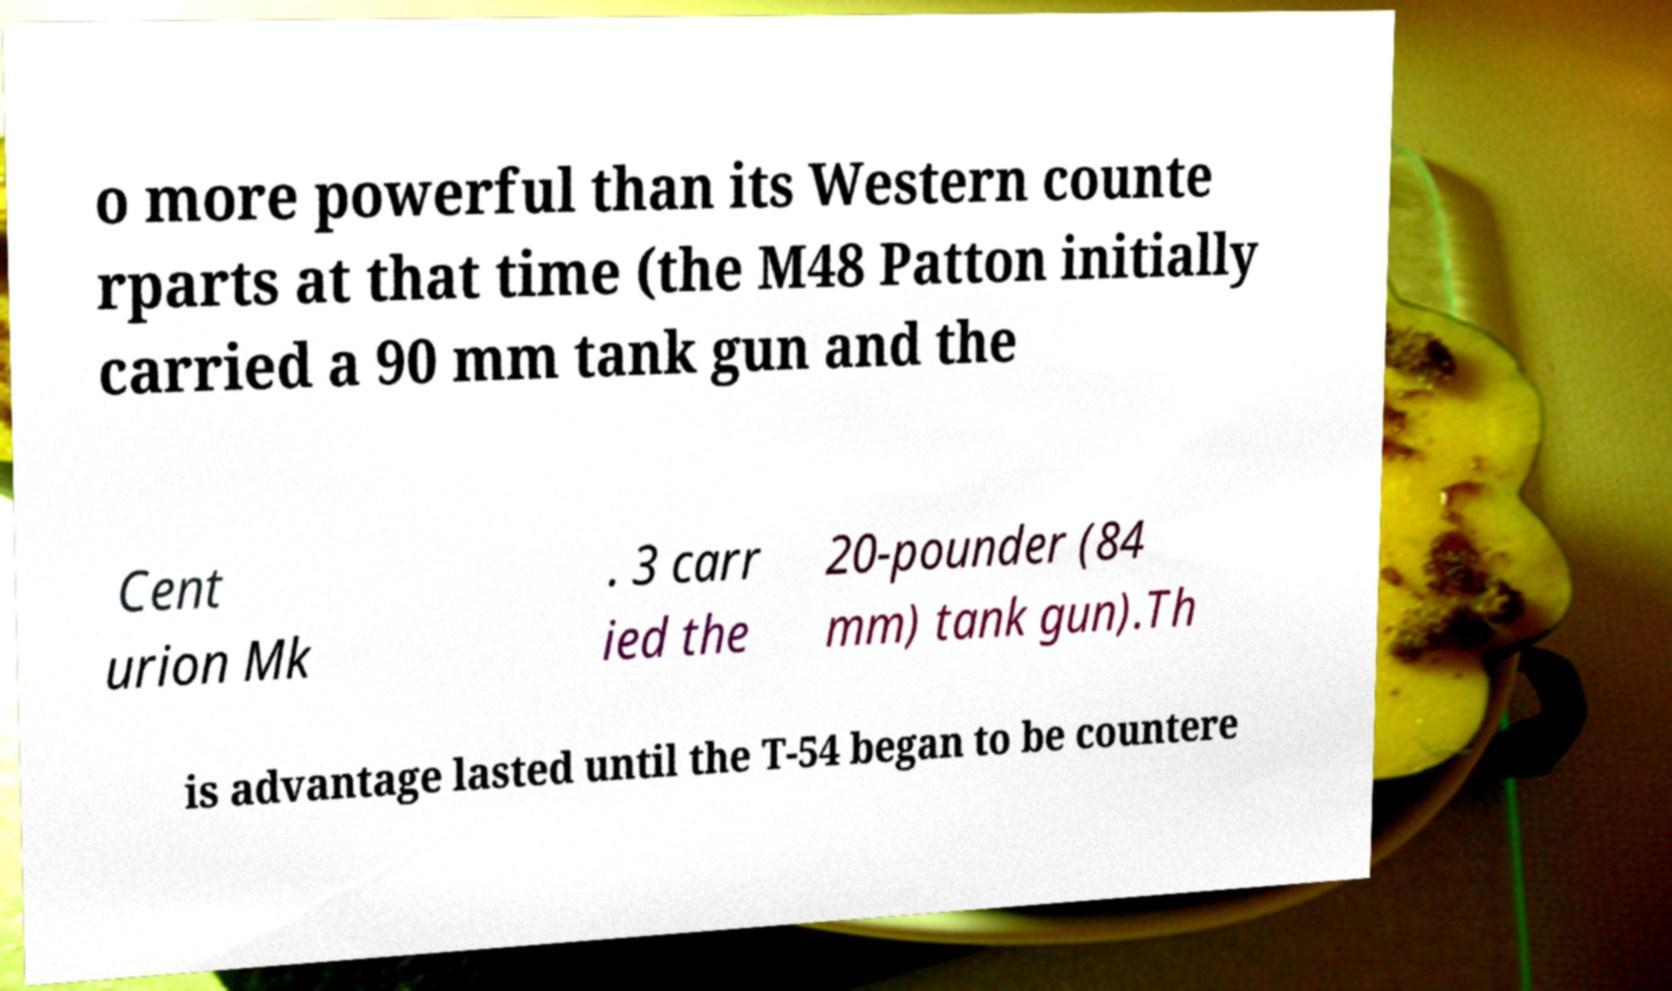Please identify and transcribe the text found in this image. o more powerful than its Western counte rparts at that time (the M48 Patton initially carried a 90 mm tank gun and the Cent urion Mk . 3 carr ied the 20-pounder (84 mm) tank gun).Th is advantage lasted until the T-54 began to be countere 